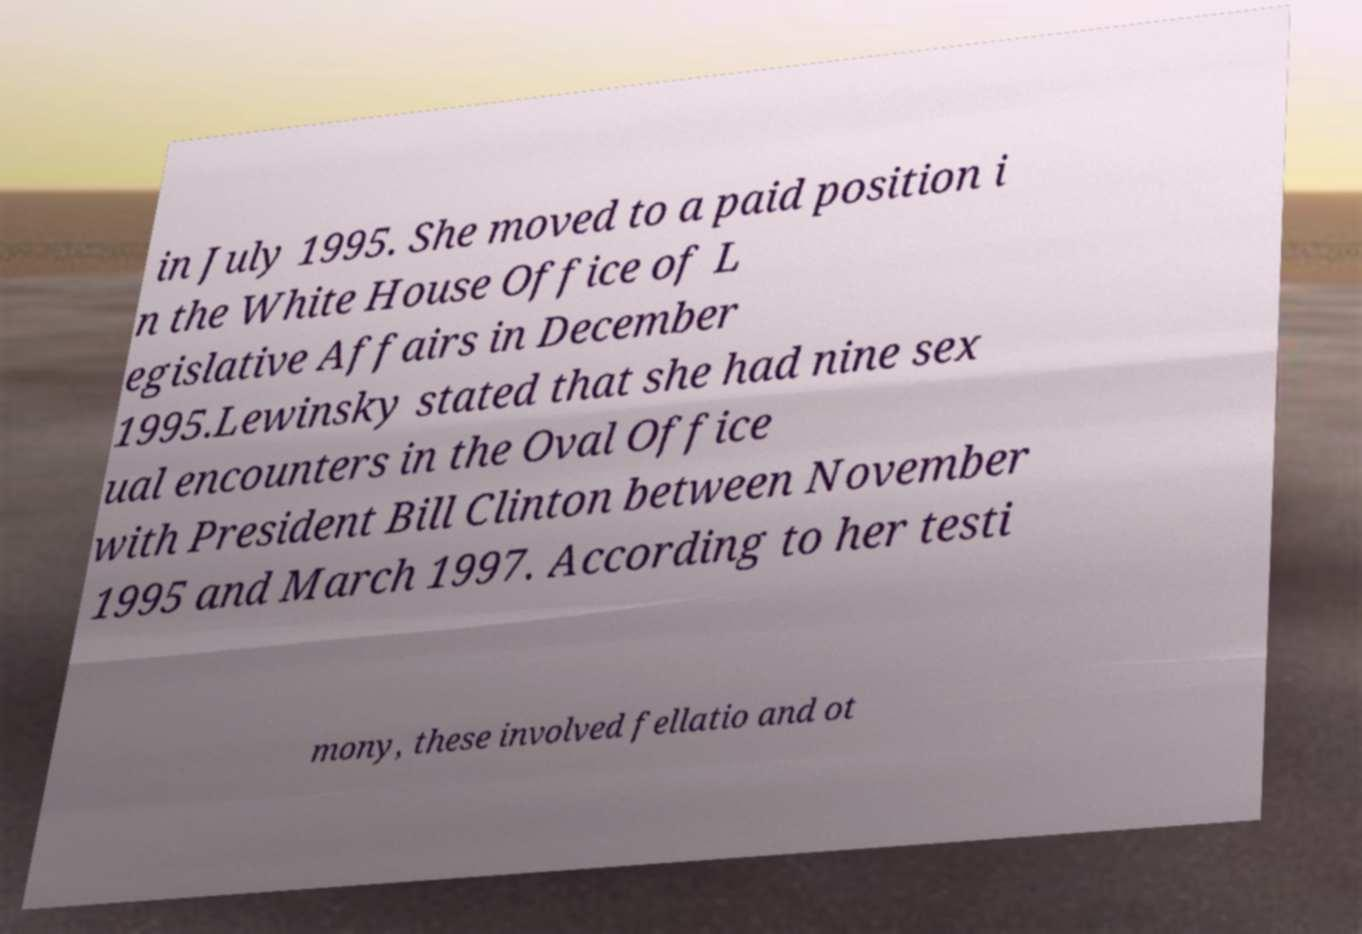Could you assist in decoding the text presented in this image and type it out clearly? in July 1995. She moved to a paid position i n the White House Office of L egislative Affairs in December 1995.Lewinsky stated that she had nine sex ual encounters in the Oval Office with President Bill Clinton between November 1995 and March 1997. According to her testi mony, these involved fellatio and ot 